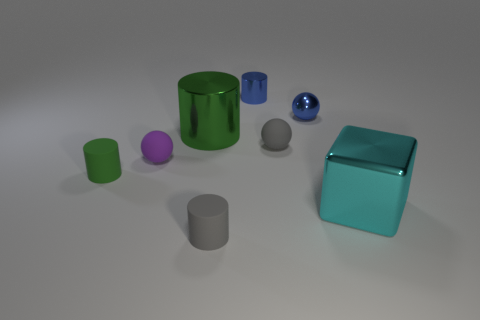Subtract all small shiny balls. How many balls are left? 2 Subtract all blocks. How many objects are left? 7 Add 1 cyan metallic cubes. How many objects exist? 9 Subtract all green cylinders. How many cylinders are left? 2 Subtract 0 red cylinders. How many objects are left? 8 Subtract 2 cylinders. How many cylinders are left? 2 Subtract all purple spheres. Subtract all red cylinders. How many spheres are left? 2 Subtract all yellow cubes. How many green cylinders are left? 2 Subtract all purple balls. Subtract all big cyan metal blocks. How many objects are left? 6 Add 7 green objects. How many green objects are left? 9 